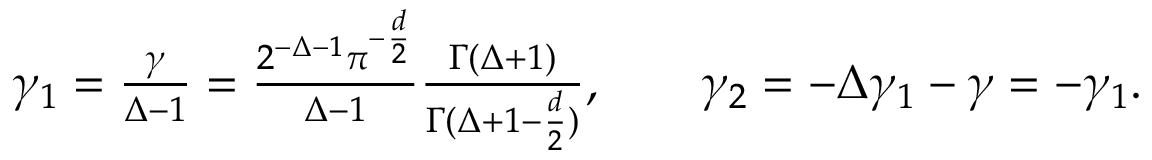Convert formula to latex. <formula><loc_0><loc_0><loc_500><loc_500>\gamma _ { 1 } = \frac { \gamma } \Delta - 1 } = \frac { 2 ^ { - \Delta - 1 } \pi ^ { - \frac { d } { 2 } } } { \Delta - 1 } \frac { \Gamma ( \Delta + 1 ) } { \Gamma ( \Delta + 1 - \frac { d } { 2 } ) } , \quad \gamma _ { 2 } = - \Delta \gamma _ { 1 } - \gamma = - \gamma _ { 1 } .</formula> 